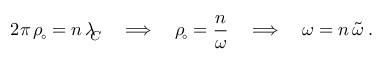<formula> <loc_0><loc_0><loc_500><loc_500>2 \pi \, \rho _ { \, \circ } = n \, \lambda _ { \, C } \quad \Longrightarrow \quad \rho _ { \, \circ } = \frac { n } { \omega } \quad \Longrightarrow \quad \omega = n \, \tilde { \omega } \, .</formula> 